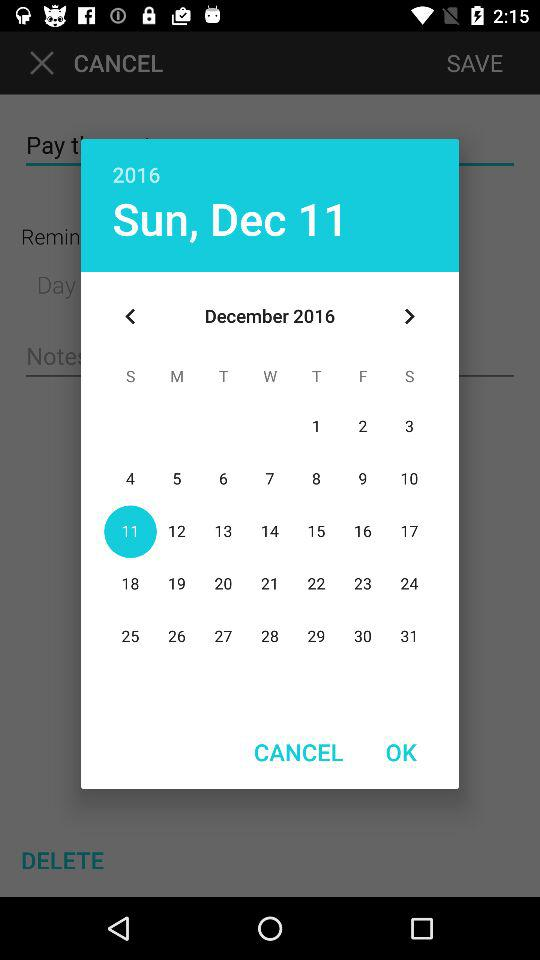What is the selected date? The selected date is Sunday, 11 December 2016. 